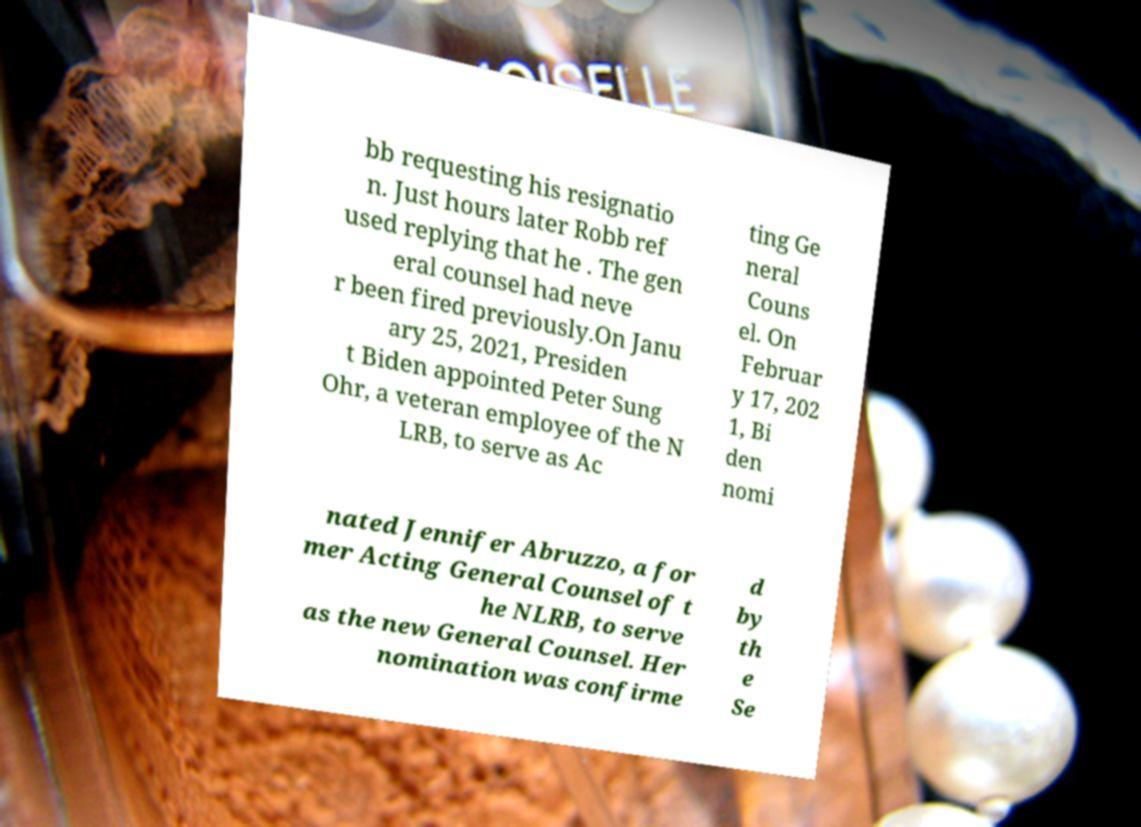Can you accurately transcribe the text from the provided image for me? bb requesting his resignatio n. Just hours later Robb ref used replying that he . The gen eral counsel had neve r been fired previously.On Janu ary 25, 2021, Presiden t Biden appointed Peter Sung Ohr, a veteran employee of the N LRB, to serve as Ac ting Ge neral Couns el. On Februar y 17, 202 1, Bi den nomi nated Jennifer Abruzzo, a for mer Acting General Counsel of t he NLRB, to serve as the new General Counsel. Her nomination was confirme d by th e Se 